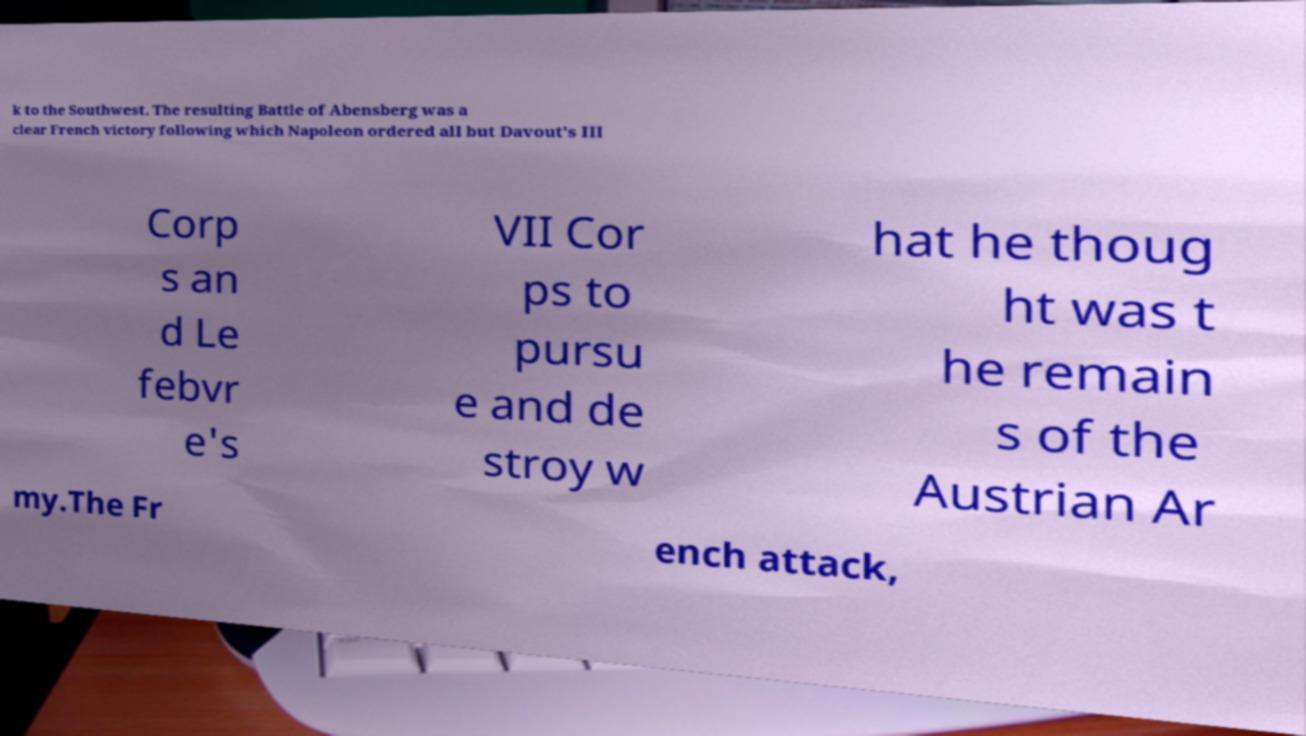Please identify and transcribe the text found in this image. k to the Southwest. The resulting Battle of Abensberg was a clear French victory following which Napoleon ordered all but Davout's III Corp s an d Le febvr e's VII Cor ps to pursu e and de stroy w hat he thoug ht was t he remain s of the Austrian Ar my.The Fr ench attack, 